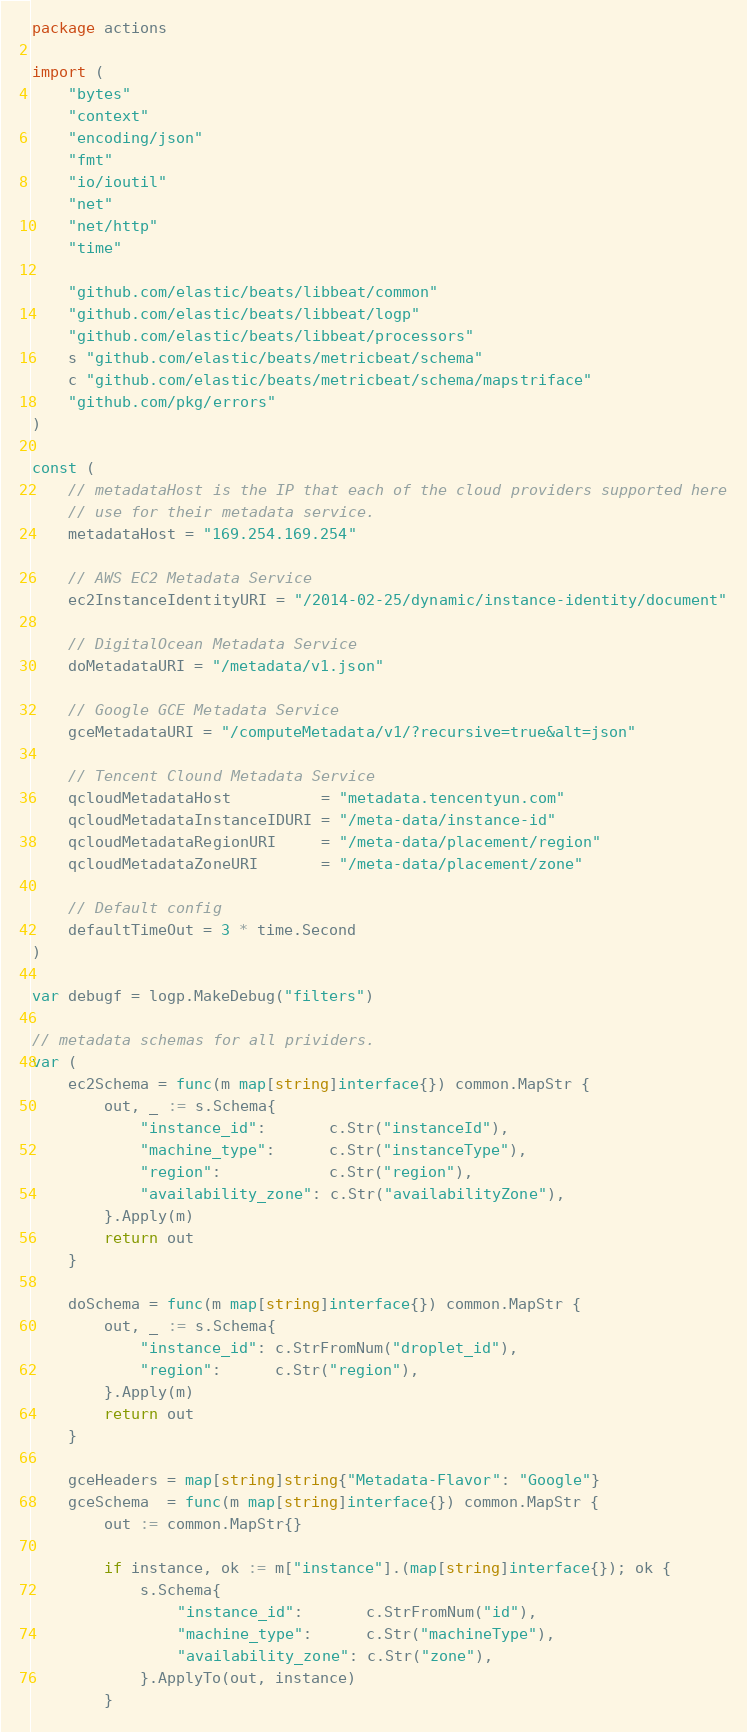<code> <loc_0><loc_0><loc_500><loc_500><_Go_>package actions

import (
	"bytes"
	"context"
	"encoding/json"
	"fmt"
	"io/ioutil"
	"net"
	"net/http"
	"time"

	"github.com/elastic/beats/libbeat/common"
	"github.com/elastic/beats/libbeat/logp"
	"github.com/elastic/beats/libbeat/processors"
	s "github.com/elastic/beats/metricbeat/schema"
	c "github.com/elastic/beats/metricbeat/schema/mapstriface"
	"github.com/pkg/errors"
)

const (
	// metadataHost is the IP that each of the cloud providers supported here
	// use for their metadata service.
	metadataHost = "169.254.169.254"

	// AWS EC2 Metadata Service
	ec2InstanceIdentityURI = "/2014-02-25/dynamic/instance-identity/document"

	// DigitalOcean Metadata Service
	doMetadataURI = "/metadata/v1.json"

	// Google GCE Metadata Service
	gceMetadataURI = "/computeMetadata/v1/?recursive=true&alt=json"

	// Tencent Clound Metadata Service
	qcloudMetadataHost          = "metadata.tencentyun.com"
	qcloudMetadataInstanceIDURI = "/meta-data/instance-id"
	qcloudMetadataRegionURI     = "/meta-data/placement/region"
	qcloudMetadataZoneURI       = "/meta-data/placement/zone"

	// Default config
	defaultTimeOut = 3 * time.Second
)

var debugf = logp.MakeDebug("filters")

// metadata schemas for all prividers.
var (
	ec2Schema = func(m map[string]interface{}) common.MapStr {
		out, _ := s.Schema{
			"instance_id":       c.Str("instanceId"),
			"machine_type":      c.Str("instanceType"),
			"region":            c.Str("region"),
			"availability_zone": c.Str("availabilityZone"),
		}.Apply(m)
		return out
	}

	doSchema = func(m map[string]interface{}) common.MapStr {
		out, _ := s.Schema{
			"instance_id": c.StrFromNum("droplet_id"),
			"region":      c.Str("region"),
		}.Apply(m)
		return out
	}

	gceHeaders = map[string]string{"Metadata-Flavor": "Google"}
	gceSchema  = func(m map[string]interface{}) common.MapStr {
		out := common.MapStr{}

		if instance, ok := m["instance"].(map[string]interface{}); ok {
			s.Schema{
				"instance_id":       c.StrFromNum("id"),
				"machine_type":      c.Str("machineType"),
				"availability_zone": c.Str("zone"),
			}.ApplyTo(out, instance)
		}
</code> 